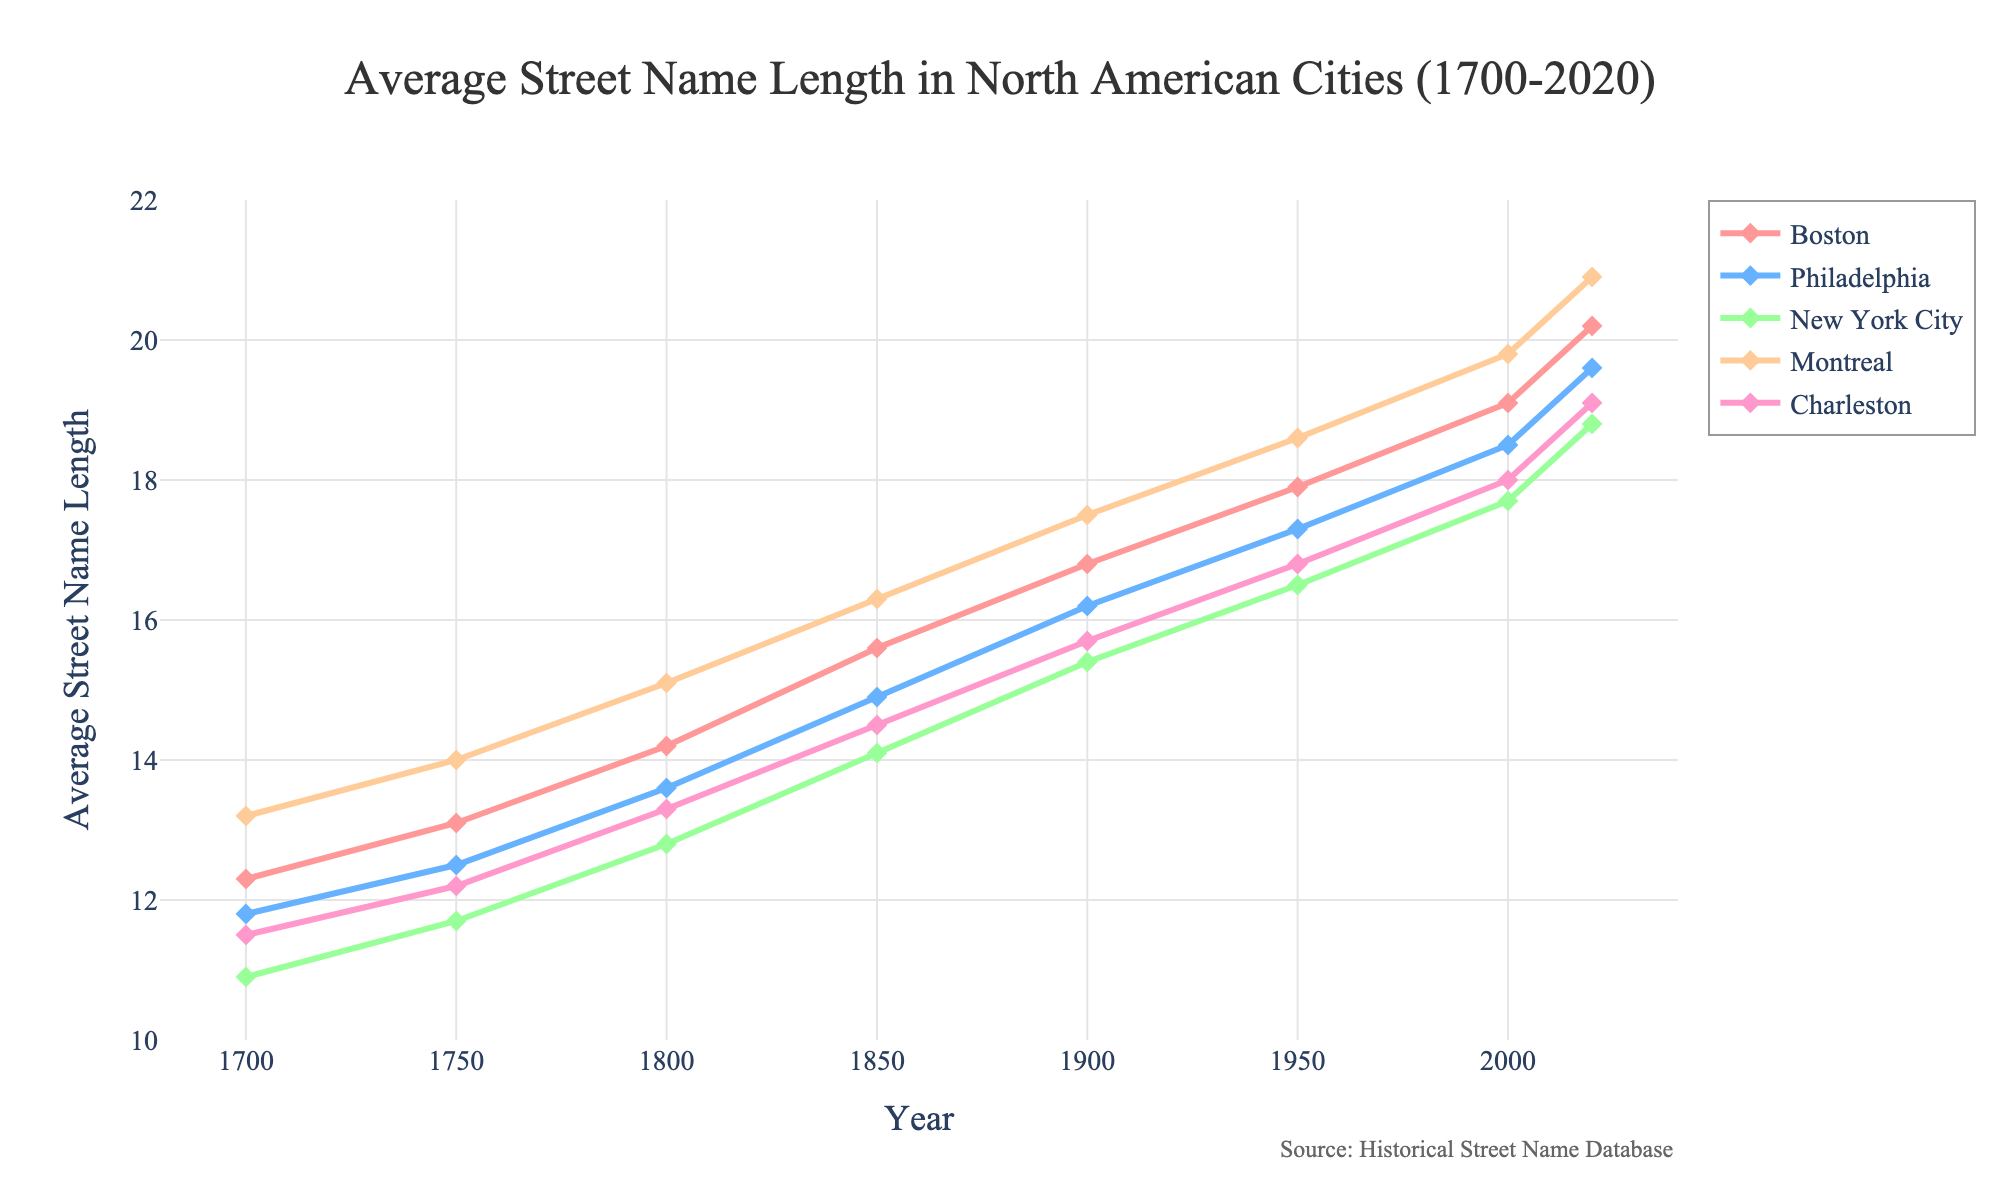When did Montreal have the highest average street name length, and what was the value? Montreal's average street name length peaks in 2020. By looking at the graph, we can see the value is at its highest point at this year.
Answer: 2020, 20.9 Which city saw the largest increase in average street name length from 1850 to 1950? Calculate the difference for each city: Boston (17.9 - 15.6 = 2.3), Philadelphia (17.3 - 14.9 = 2.4), New York City (16.5 - 14.1 = 2.4), Montreal (18.6 - 16.3 = 2.3), Charleston (16.8 - 14.5 = 2.3). Both Philadelphia and New York City saw an increase of 2.4 characters.
Answer: Philadelphia, New York City Between which years did Montreal show an increment of more than 1 in average street name length? Identify segments where the increase is more than 1: 1750-1800 (14.0 to 15.1), 1800-1850 (15.1 to 16.3), 1850-1900 (16.3 to 17.5), 1950-2000 (18.6 to 19.8), 2000-2020 (19.8 to 20.9). Each segment shows increments of more than 1.
Answer: 1750-1800, 1800-1850, 1850-1900, 1950-2000, 2000-2020 What is the difference in average street name length between Boston and Charleston in 2020? Look at the graph to find the values in 2020: Boston (20.2), Charleston (19.1). Calculate the difference: 20.2 - 19.1 = 1.1.
Answer: 1.1 Which city had the least average street name length in 1750, and what was the length? Compare the values for each city in 1750: Boston (13.1), Philadelphia (12.5), New York City (11.7), Montreal (14.0), Charleston (12.2). New York City has the least with 11.7.
Answer: New York City, 11.7 Did any city have a consistent increase in average street name length every recorded year? Check each city's trend in the graph. All five cities (Boston, Philadelphia, New York City, Montreal, Charleston) show consistent increases at every recorded time point.
Answer: Yes, all cities From 1700 to 1800, which city experienced the greatest total increase in average street name length? Calculate the total increase for each city: Boston (14.2 - 12.3 = 1.9), Philadelphia (13.6 - 11.8 = 1.8), New York City (12.8 - 10.9 = 1.9), Montreal (15.1 - 13.2 = 1.9), Charleston (13.3 - 11.5 = 1.8). Boston, New York City, and Montreal each had an increase of 1.9.
Answer: Boston, New York City, Montreal 